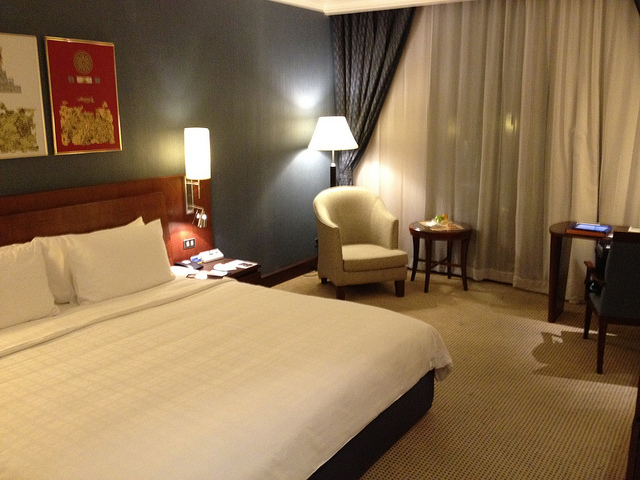How many beds are in this room? There is one bed in the room, which looks comfortable with a well-made white duvet and plush pillows; it seems to be a full or queen size, ideal for relaxation or a good night's sleep. 